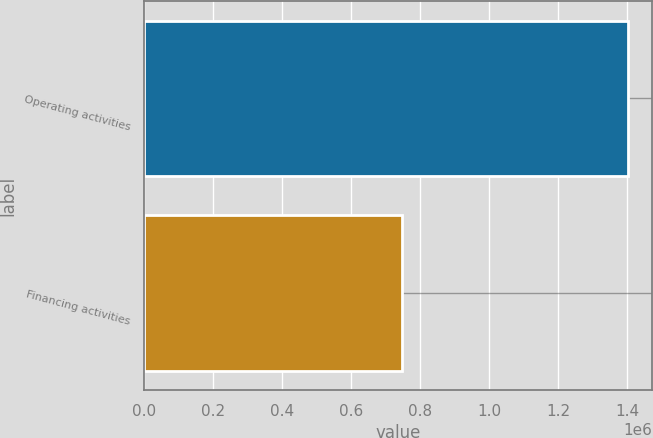Convert chart. <chart><loc_0><loc_0><loc_500><loc_500><bar_chart><fcel>Operating activities<fcel>Financing activities<nl><fcel>1.40292e+06<fcel>748250<nl></chart> 